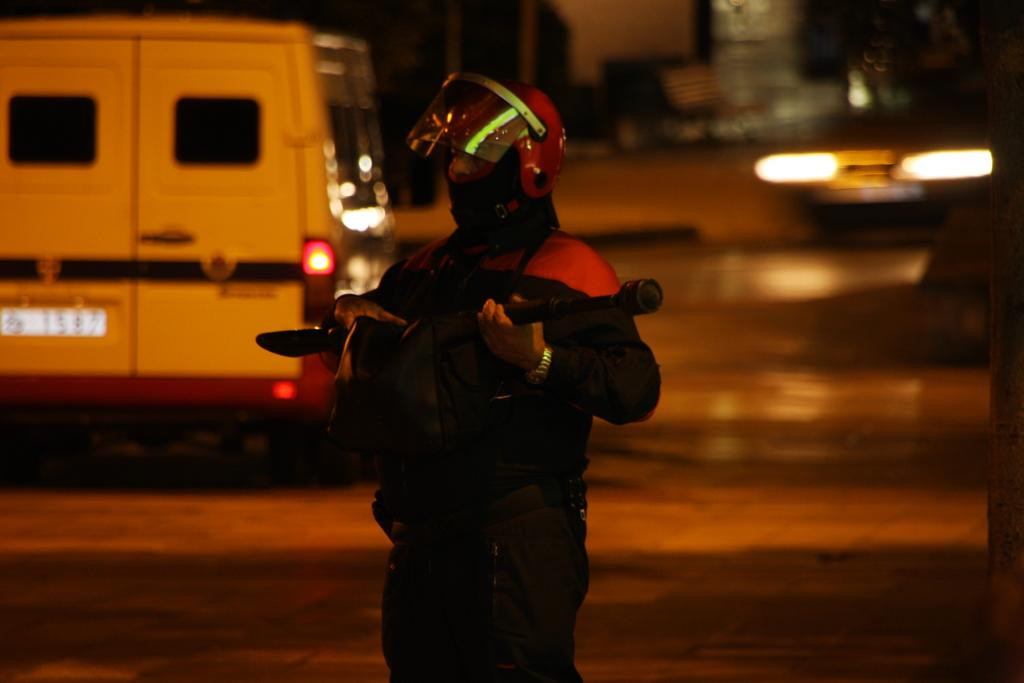What can be seen in the image? There is a person in the image. What is the person holding? The person is holding an object. What type of protective gear is the person wearing? The person is wearing a helmet. Can you describe the background of the image? The background of the image is blurred. What else can be seen in the background? There are vehicles and other objects visible in the background. What route is the person feeling ashamed about in the image? There is no indication of a route or any feelings of shame in the image. 